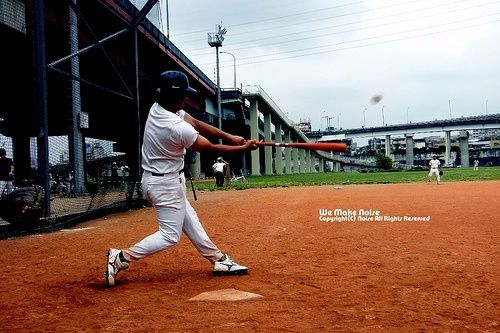Describe the objects in this image and their specific colors. I can see people in black, darkgray, lightgray, and gray tones, baseball bat in black, maroon, brown, and salmon tones, people in black, gray, navy, and darkgray tones, people in black, white, olive, and maroon tones, and people in black, lightgray, darkgray, and tan tones in this image. 